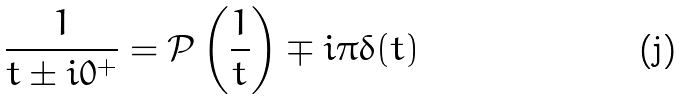<formula> <loc_0><loc_0><loc_500><loc_500>\frac { 1 } { t \pm i 0 ^ { + } } = { \mathcal { P } } \left ( \frac { 1 } { t } \right ) \mp i \pi \delta ( t )</formula> 